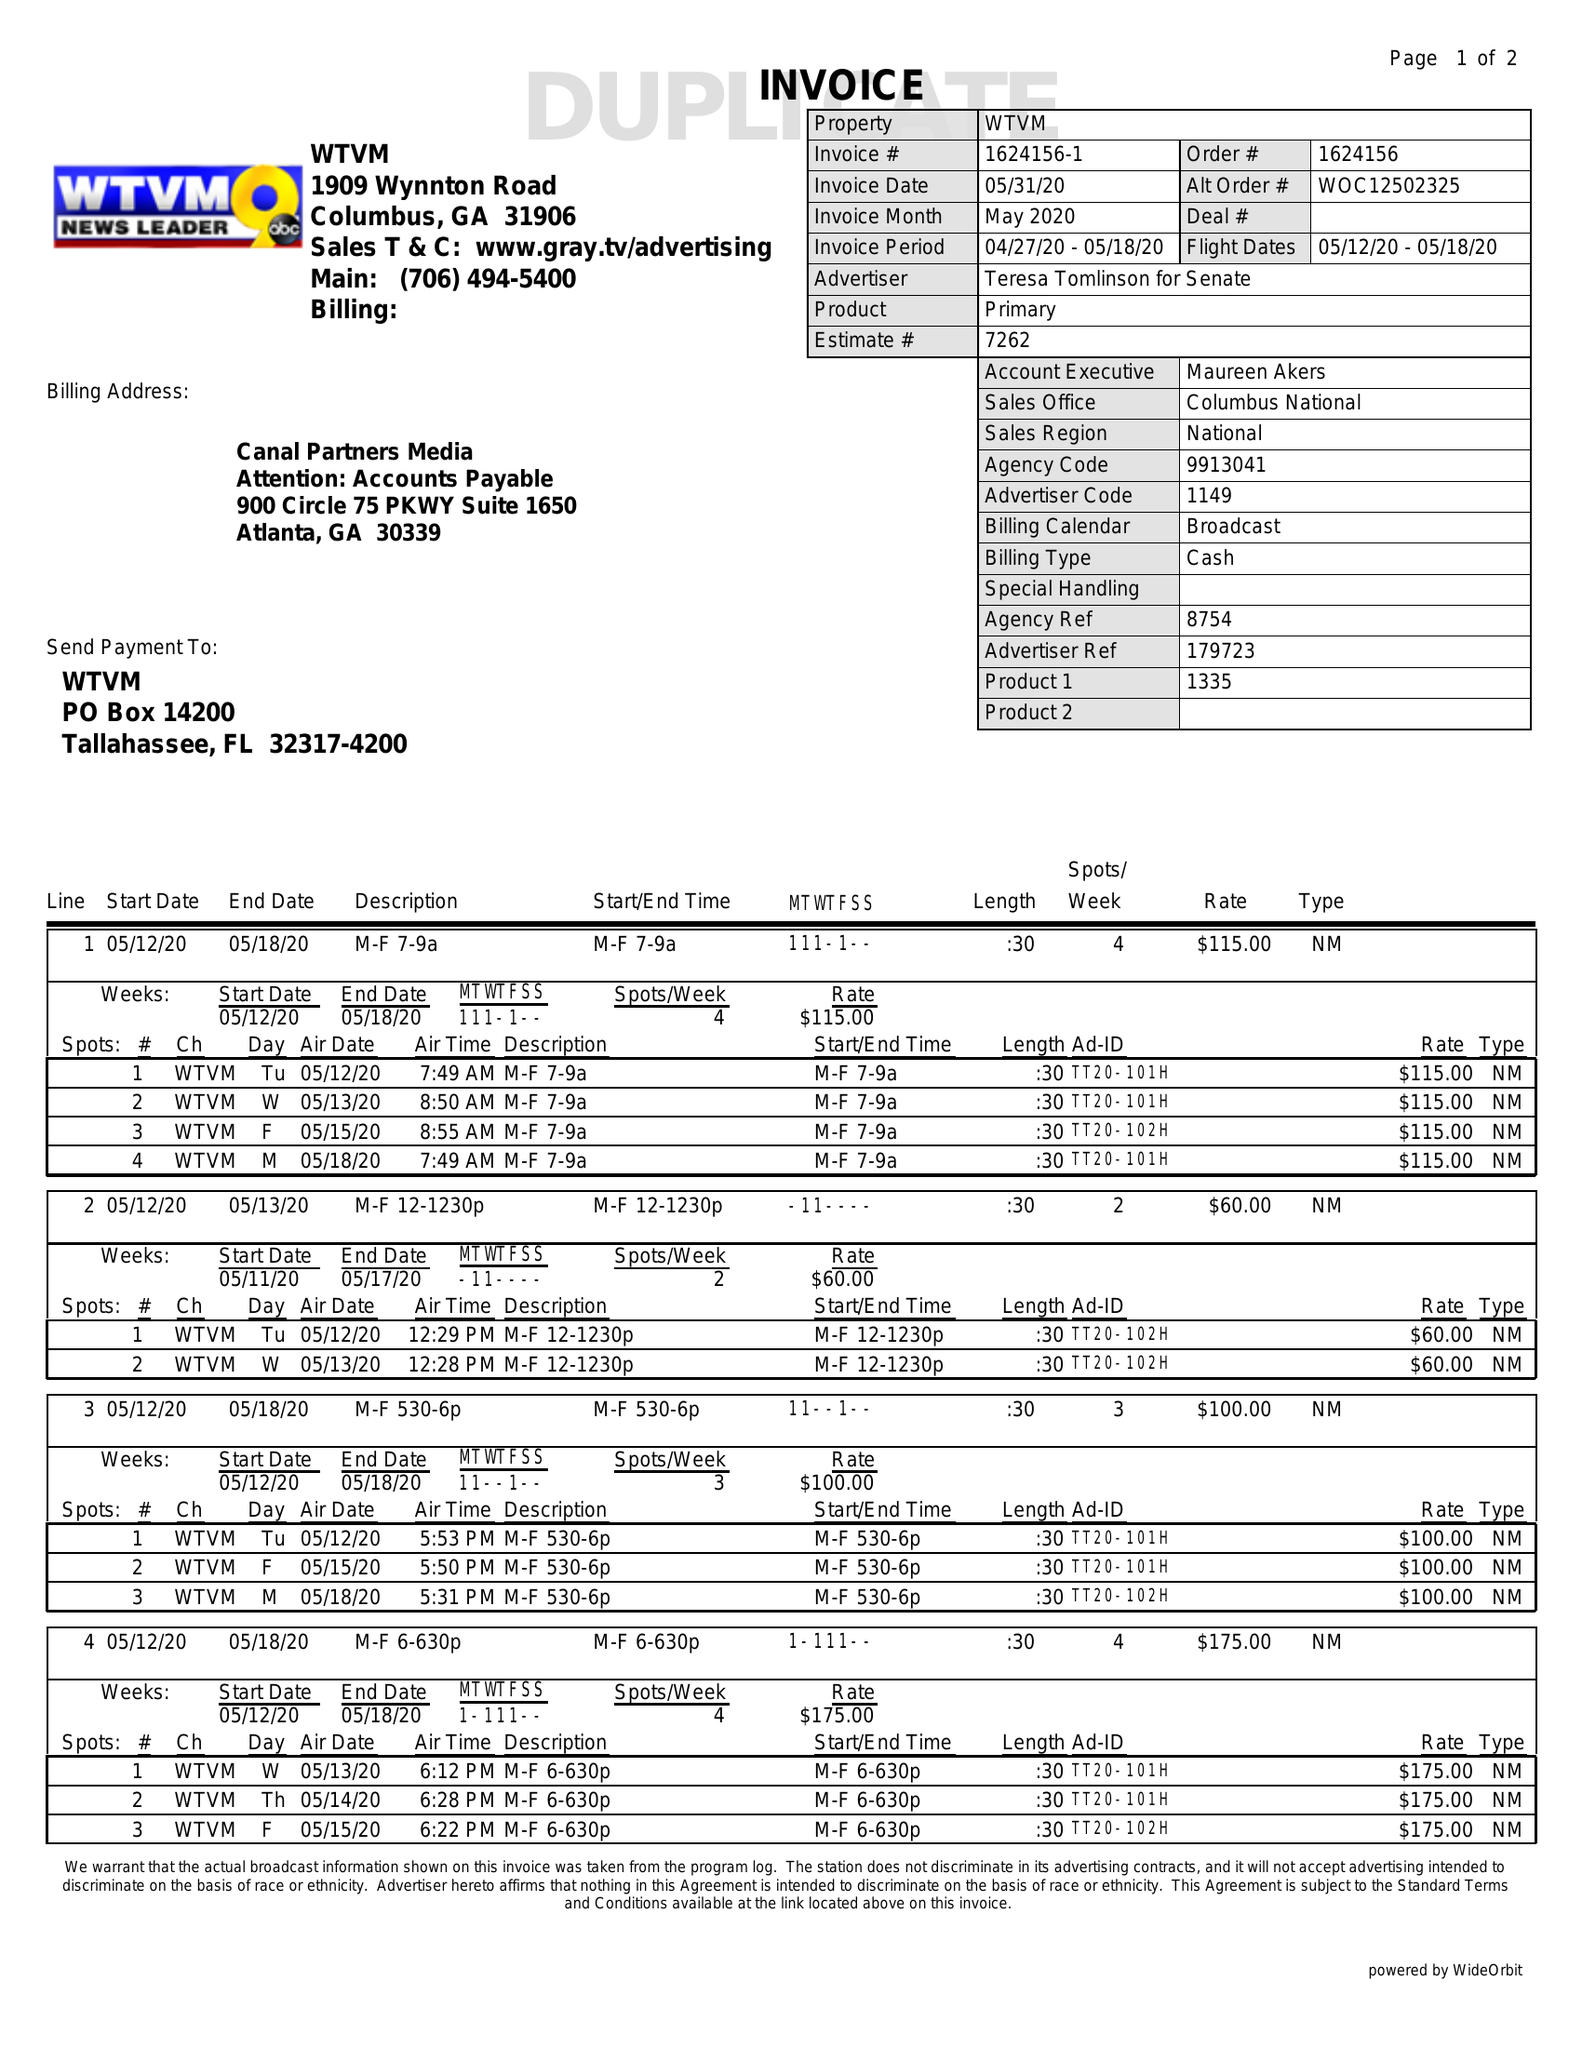What is the value for the advertiser?
Answer the question using a single word or phrase. TERESA TOMLINSON FOR SENATE 